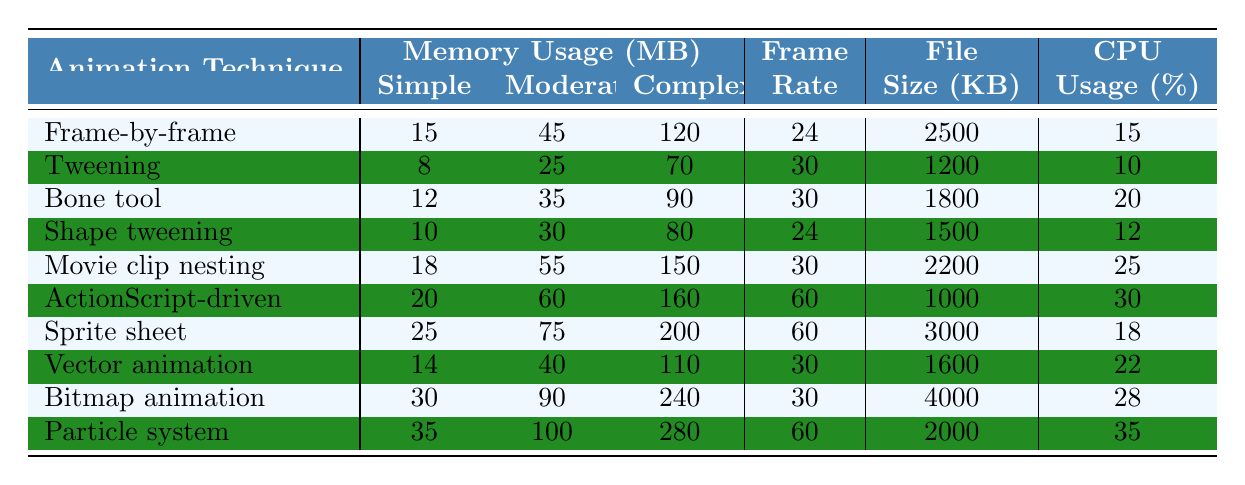What is the memory usage for `Movie clip nesting` at a `Complex` level? From the table, the memory usage for `Movie clip nesting` under the `Complex` category is explicitly listed as 150 MB.
Answer: 150 MB Which animation technique has the highest memory usage for `Simple` projects? By scanning the `Simple` memory usage values for each technique, `Particle system` has the highest value at 35 MB.
Answer: 35 MB What is the average memory usage for `Moderate` complexity across all techniques? To find the average, first sum the moderate memory values: (45 + 25 + 35 + 30 + 55 + 60 + 75 + 40 + 90 + 100) = 510. There are 10 techniques, so the average is 510 / 10 = 51.
Answer: 51 MB Does `Sprite sheet animation` have a higher CPU usage than `Shape tweening`? Comparing the CPU usage values, `Sprite sheet animation` has 18% while `Shape tweening` has 12%. Since 18% is greater than 12%, the statement is true.
Answer: Yes Which technique has the lowest file size? From the file size column, `ActionScript-driven animation` has the lowest file size at 1000 KB.
Answer: 1000 KB What is the difference in memory usage for `Bitmap animation` between `Simple` and `Complex` levels? The memory usage for `Bitmap animation` is 30 MB for `Simple` and 240 MB for `Complex`. The difference is calculated as 240 - 30 = 210 MB.
Answer: 210 MB Which animation technique is the most CPU intensive in a `Complex` project? Scanning through the CPU usage for `Complex` projects, `Particle system` has the highest usage with 35%.
Answer: 35% Are there any animation techniques that have the same frame rate? Looking through the frame rates, `Tweening`, `Bone tool`, `Movie clip nesting`, `Bitmap animation`, and `Vector animation` all have a frame rate of 30. Thus, yes, there are techniques with the same frame rate.
Answer: Yes If you wanted to choose a technique that uses less than 20 MB for `Simple` projects, which ones would you consider? Reviewing the `Simple` memory values, the techniques that use less than 20 MB are `Tweening` (8 MB), `Bone tool` (12 MB), and `Shape tweening` (10 MB).
Answer: Tweening, Bone tool, Shape tweening What is the highest `Frame Rate` achieved by the animation techniques? The highest frame rate listed in the table is 60 from `ActionScript-driven animation`, `Sprite sheet animation`, and `Particle system`.
Answer: 60 